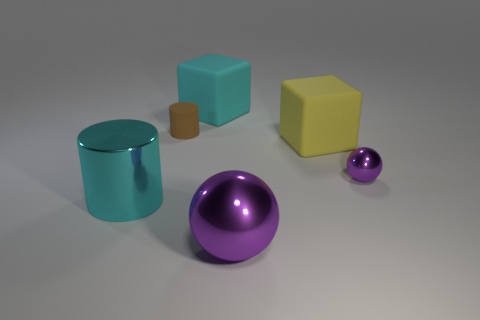Is there any other thing that has the same color as the big sphere? Indeed, there is an item with a color that matches the large sphere; it's the smaller sphere to the right. They both share a strikingly similar shade of purple, setting a visual connection between the two amongst the array of objects presented. 